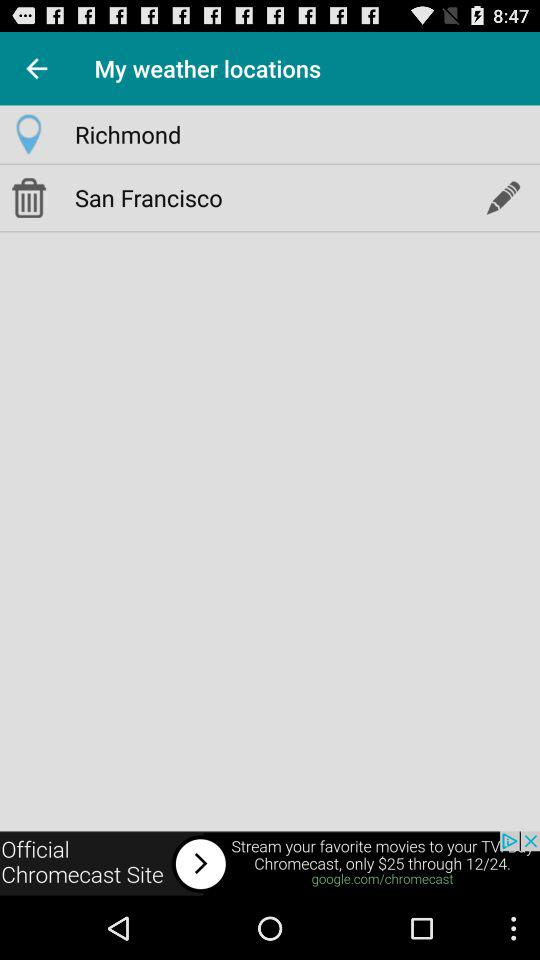How many locations are there?
Answer the question using a single word or phrase. 2 